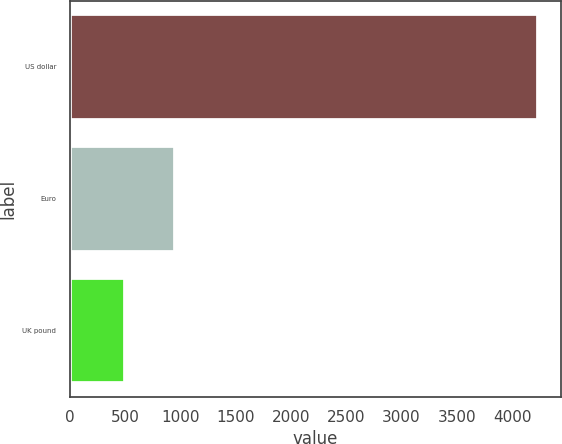Convert chart. <chart><loc_0><loc_0><loc_500><loc_500><bar_chart><fcel>US dollar<fcel>Euro<fcel>UK pound<nl><fcel>4232<fcel>955<fcel>498<nl></chart> 